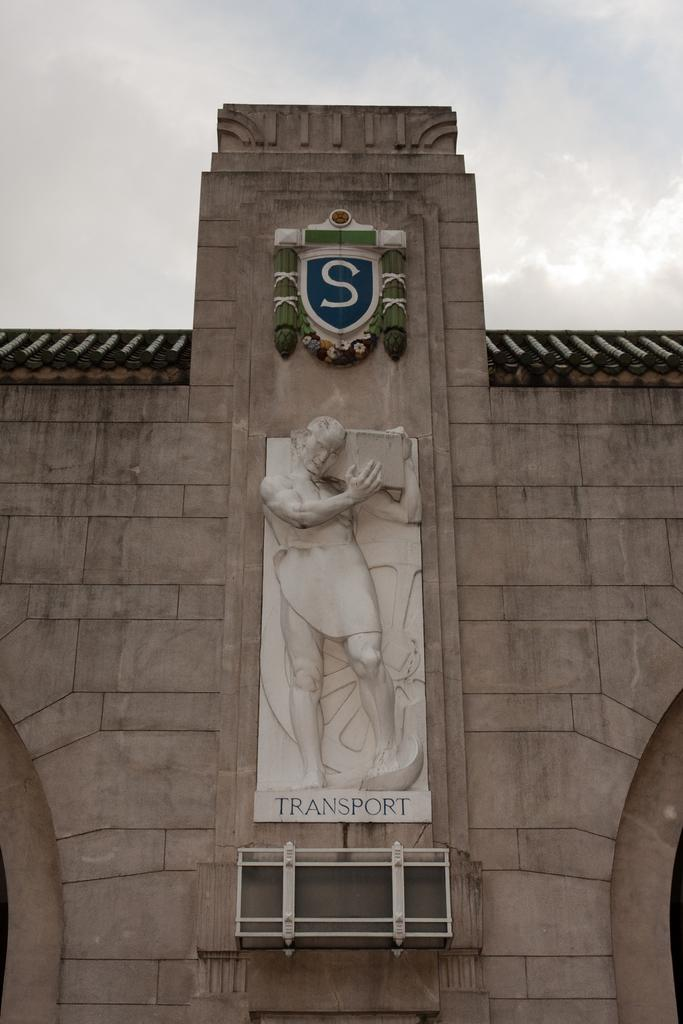Provide a one-sentence caption for the provided image. The outside of a building displaying the sculpture of a man carrying something above the word transport. 